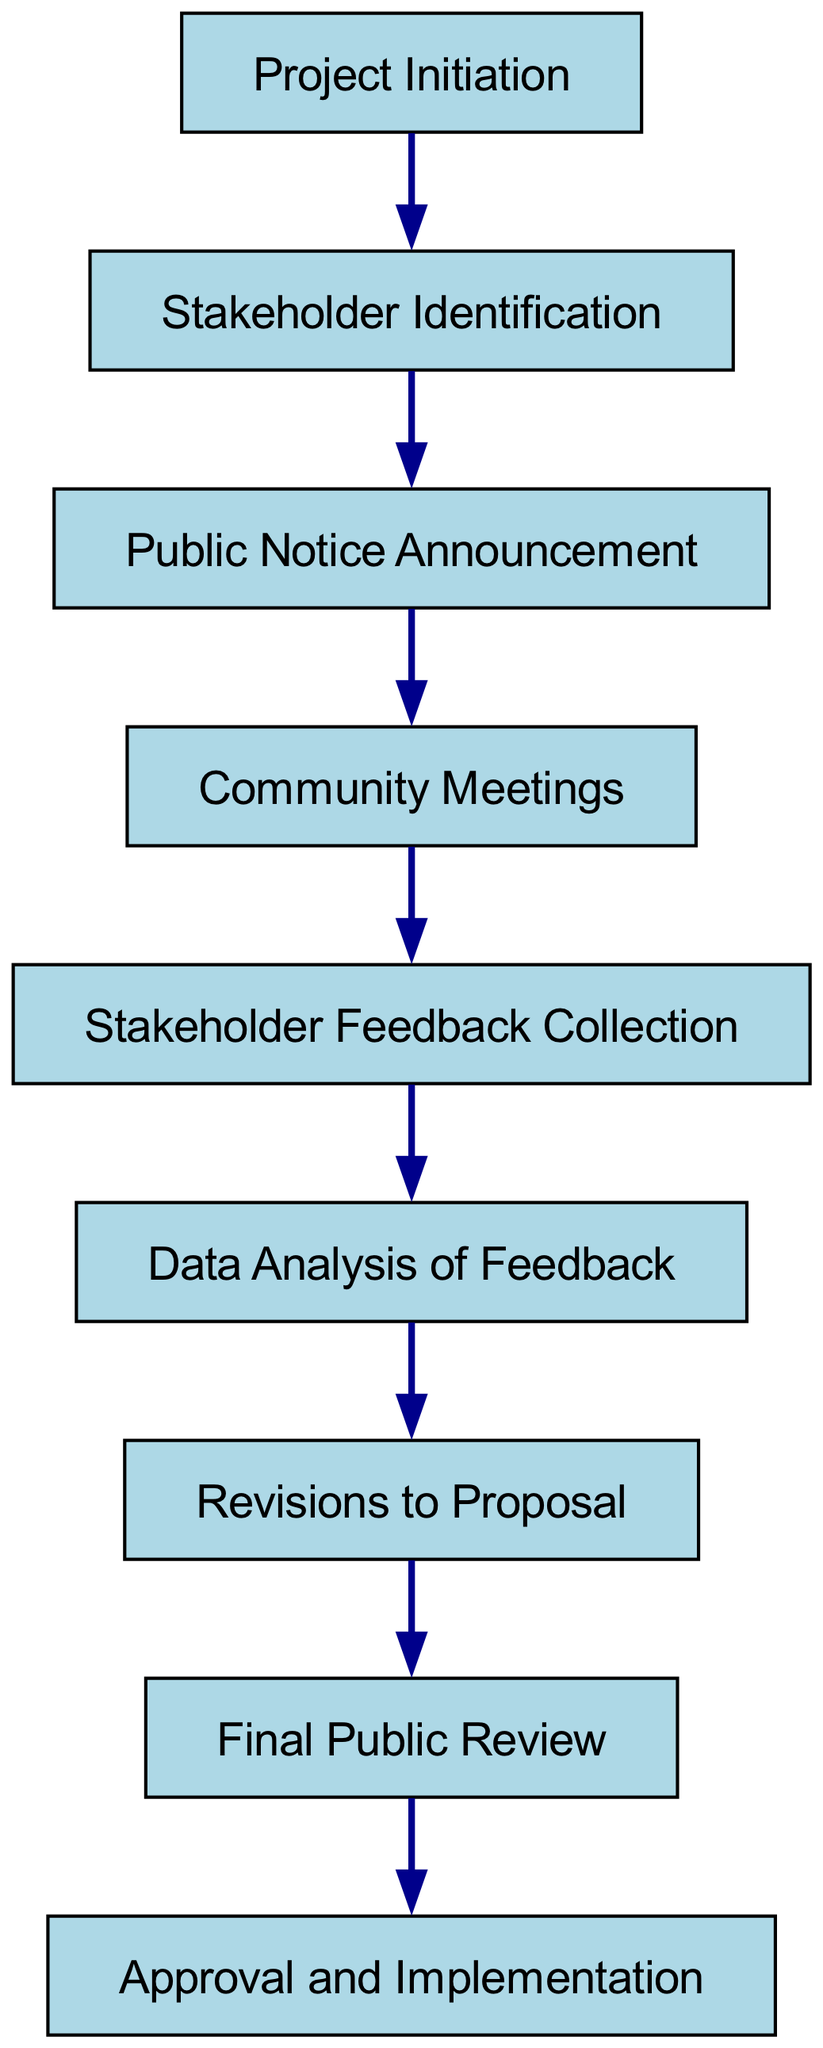What is the first step in the public consultation process? The diagram indicates that "Project Initiation" is the first node in the sequence. It is connected to the following node, which is "Stakeholder Identification."
Answer: Project Initiation How many nodes are present in the directed graph? Counting the nodes listed in the diagram, we see there are a total of nine nodes from "Project Initiation" to "Approval and Implementation."
Answer: Nine What comes immediately after "Community Meetings"? According to the edges in the diagram, "Stakeholder Feedback Collection" follows "Community Meetings," indicating the direct relationship between these two nodes.
Answer: Stakeholder Feedback Collection Which node represents the final step of the process? The last node is "Approval and Implementation," which does not lead to any further nodes, confirming it as the concluding step in the public consultation process.
Answer: Approval and Implementation How many edges are there in this diagram? The diagram includes eight edges connecting the nodes, representing the flow of the public consultation process.
Answer: Eight What is the relationship between "Data Analysis of Feedback" and "Revisions to Proposal"? The edge from node "Data Analysis of Feedback" leads to the node "Revisions to Proposal," showing that analysis directly informs proposal revisions.
Answer: Data Analysis of Feedback informs Revisions to Proposal If stakeholder feedback is collected, where does it lead? After collecting feedback, the next step as per the diagram is "Data Analysis of Feedback," indicating the sequence of actions that follow stakeholder engagement.
Answer: Data Analysis of Feedback What step precedes the "Final Public Review"? "Revisions to Proposal" comes right before "Final Public Review," showing the sequence where revisions are made before the public can review the final proposal.
Answer: Revisions to Proposal What indicates stakeholder engagement within the process? "Community Meetings" is specifically designed to engage stakeholders, as shown in the diagram where it connects to feedback collection.
Answer: Community Meetings 